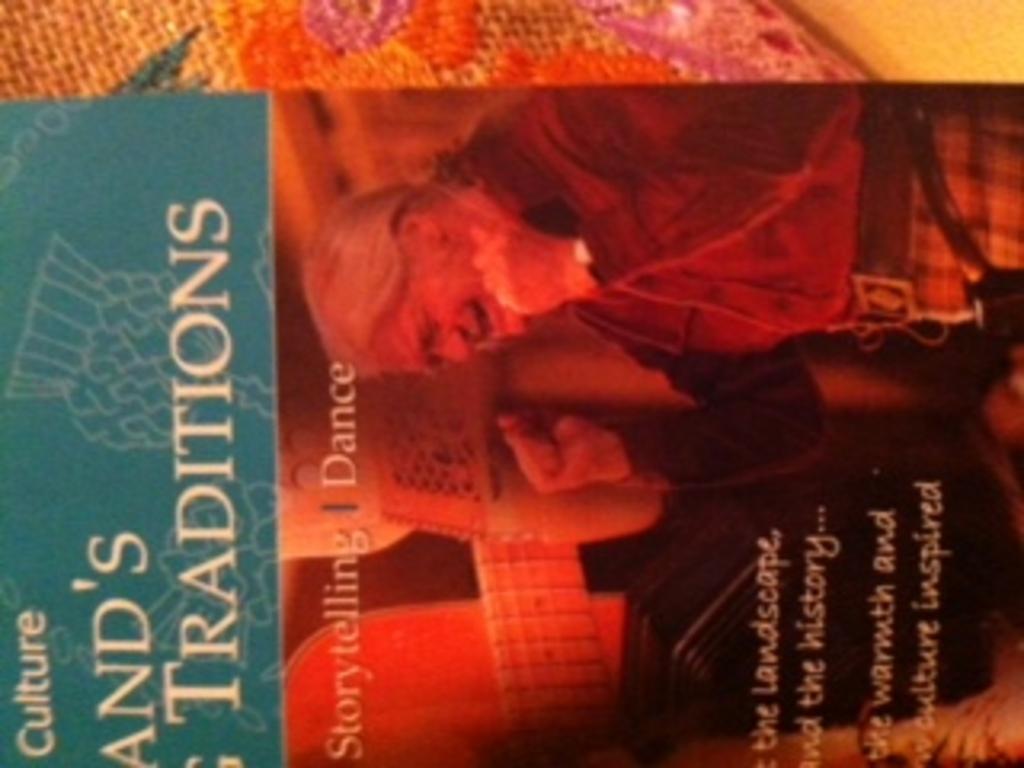What two activities are listed on the book, at the top of the red part of the image?
Offer a very short reply. Storytelling, dance. 